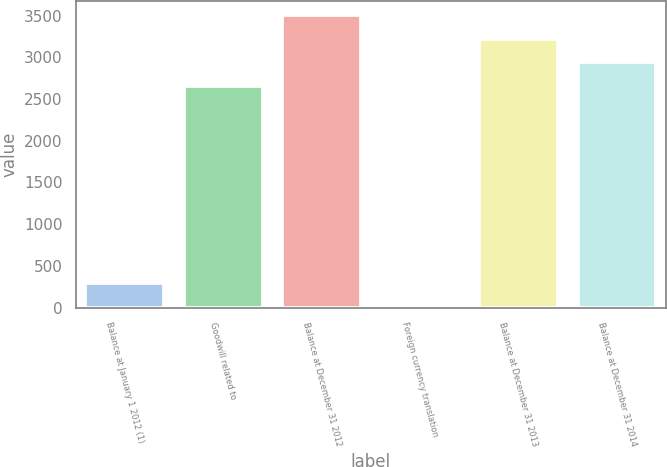Convert chart. <chart><loc_0><loc_0><loc_500><loc_500><bar_chart><fcel>Balance at January 1 2012 (1)<fcel>Goodwill related to<fcel>Balance at December 31 2012<fcel>Foreign currency translation<fcel>Balance at December 31 2013<fcel>Balance at December 31 2014<nl><fcel>297.2<fcel>2661<fcel>3504.6<fcel>16<fcel>3223.4<fcel>2942.2<nl></chart> 